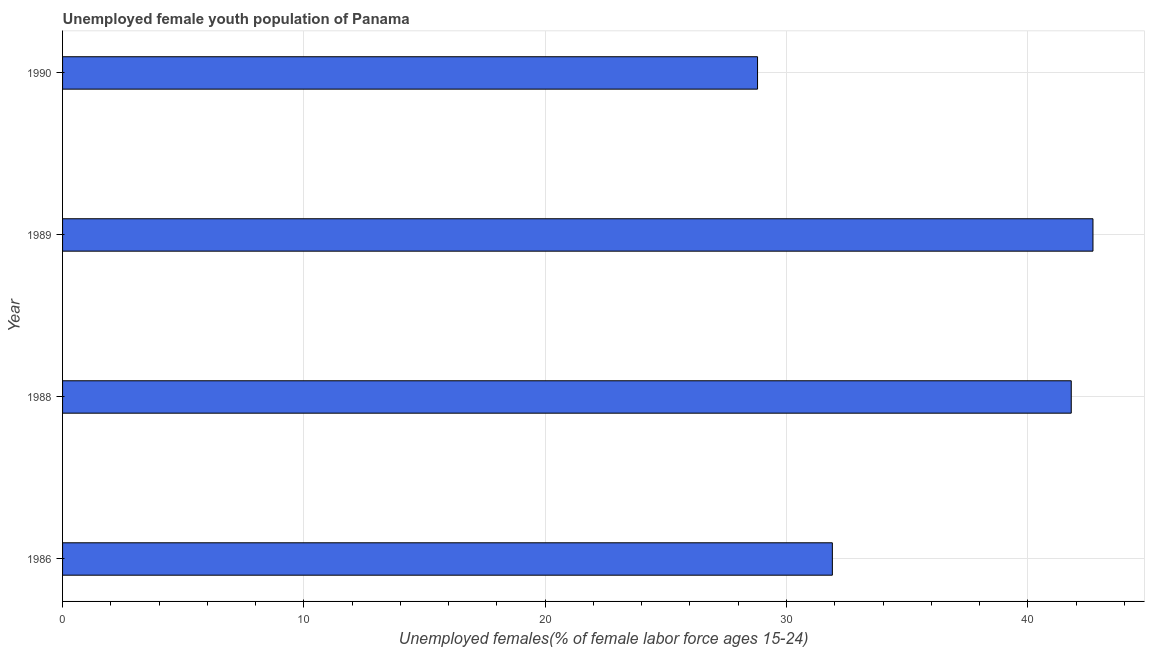Does the graph contain grids?
Give a very brief answer. Yes. What is the title of the graph?
Provide a succinct answer. Unemployed female youth population of Panama. What is the label or title of the X-axis?
Give a very brief answer. Unemployed females(% of female labor force ages 15-24). What is the unemployed female youth in 1989?
Provide a short and direct response. 42.7. Across all years, what is the maximum unemployed female youth?
Make the answer very short. 42.7. Across all years, what is the minimum unemployed female youth?
Make the answer very short. 28.8. In which year was the unemployed female youth minimum?
Your answer should be very brief. 1990. What is the sum of the unemployed female youth?
Give a very brief answer. 145.2. What is the average unemployed female youth per year?
Provide a short and direct response. 36.3. What is the median unemployed female youth?
Give a very brief answer. 36.85. Do a majority of the years between 1986 and 1988 (inclusive) have unemployed female youth greater than 40 %?
Keep it short and to the point. No. What is the ratio of the unemployed female youth in 1986 to that in 1989?
Your answer should be compact. 0.75. Is the difference between the unemployed female youth in 1986 and 1990 greater than the difference between any two years?
Your answer should be compact. No. Is the sum of the unemployed female youth in 1986 and 1988 greater than the maximum unemployed female youth across all years?
Make the answer very short. Yes. What is the difference between the highest and the lowest unemployed female youth?
Give a very brief answer. 13.9. In how many years, is the unemployed female youth greater than the average unemployed female youth taken over all years?
Your response must be concise. 2. How many bars are there?
Offer a terse response. 4. How many years are there in the graph?
Offer a very short reply. 4. Are the values on the major ticks of X-axis written in scientific E-notation?
Your answer should be compact. No. What is the Unemployed females(% of female labor force ages 15-24) of 1986?
Your response must be concise. 31.9. What is the Unemployed females(% of female labor force ages 15-24) in 1988?
Your answer should be very brief. 41.8. What is the Unemployed females(% of female labor force ages 15-24) of 1989?
Your answer should be compact. 42.7. What is the Unemployed females(% of female labor force ages 15-24) in 1990?
Your answer should be compact. 28.8. What is the difference between the Unemployed females(% of female labor force ages 15-24) in 1986 and 1988?
Provide a succinct answer. -9.9. What is the difference between the Unemployed females(% of female labor force ages 15-24) in 1986 and 1989?
Offer a very short reply. -10.8. What is the difference between the Unemployed females(% of female labor force ages 15-24) in 1988 and 1989?
Ensure brevity in your answer.  -0.9. What is the difference between the Unemployed females(% of female labor force ages 15-24) in 1989 and 1990?
Make the answer very short. 13.9. What is the ratio of the Unemployed females(% of female labor force ages 15-24) in 1986 to that in 1988?
Offer a terse response. 0.76. What is the ratio of the Unemployed females(% of female labor force ages 15-24) in 1986 to that in 1989?
Provide a short and direct response. 0.75. What is the ratio of the Unemployed females(% of female labor force ages 15-24) in 1986 to that in 1990?
Your response must be concise. 1.11. What is the ratio of the Unemployed females(% of female labor force ages 15-24) in 1988 to that in 1990?
Your response must be concise. 1.45. What is the ratio of the Unemployed females(% of female labor force ages 15-24) in 1989 to that in 1990?
Provide a short and direct response. 1.48. 